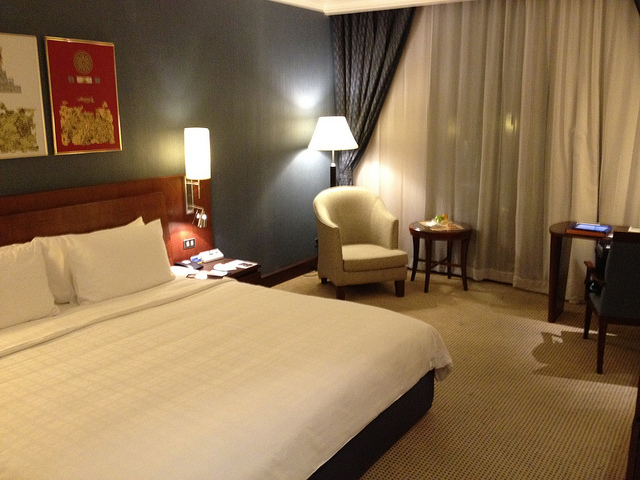Tell me more about the decor and ambiance of this room. The room's decor is modern and understated, with a neutral color palette that includes a dark gray wall and lighter floor. The artwork, curtains, and clean lines of the furniture add a touch of elegance. The lighting is gentle and warm, contributing to a cozy and inviting ambiance. 